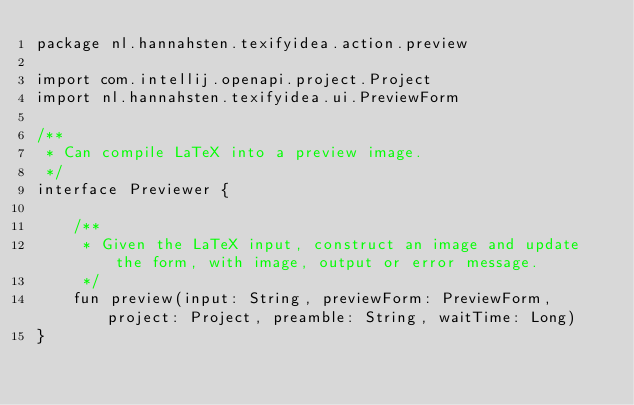<code> <loc_0><loc_0><loc_500><loc_500><_Kotlin_>package nl.hannahsten.texifyidea.action.preview

import com.intellij.openapi.project.Project
import nl.hannahsten.texifyidea.ui.PreviewForm

/**
 * Can compile LaTeX into a preview image.
 */
interface Previewer {

    /**
     * Given the LaTeX input, construct an image and update the form, with image, output or error message.
     */
    fun preview(input: String, previewForm: PreviewForm, project: Project, preamble: String, waitTime: Long)
}</code> 